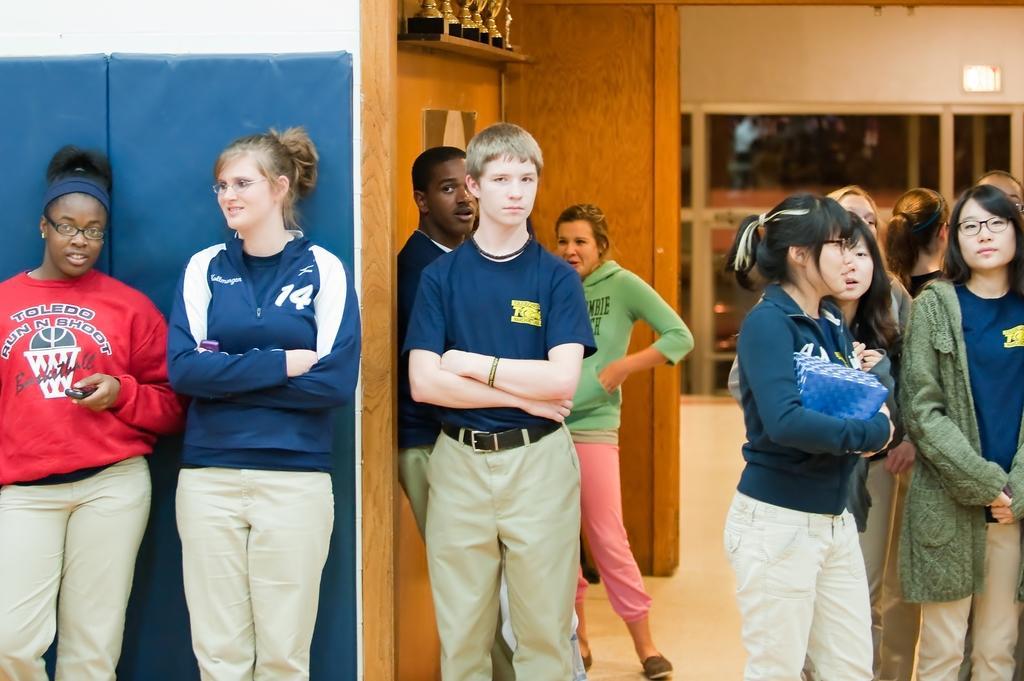How would you summarize this image in a sentence or two? As we can see in the image there is a wall, few people here and there, window and shields. 